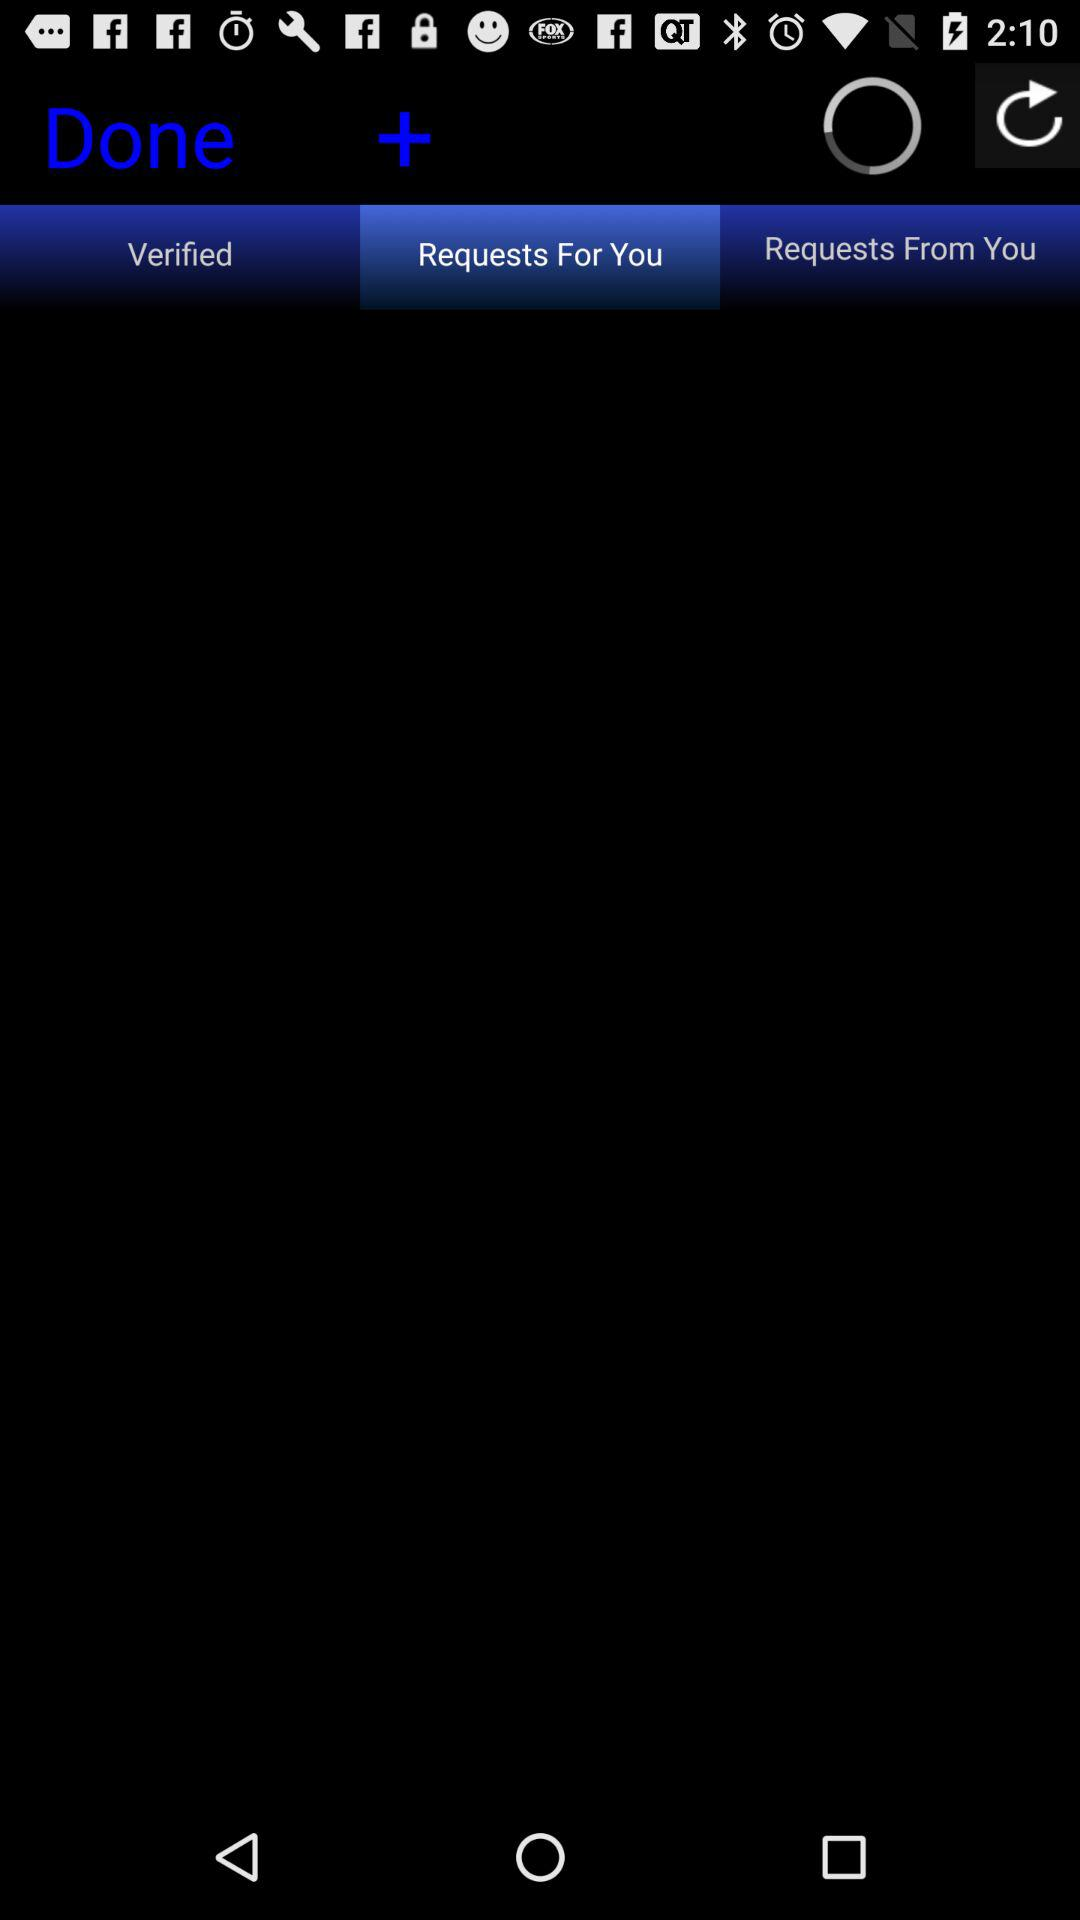Which tab is selected? The selected tab is "Requests For You". 